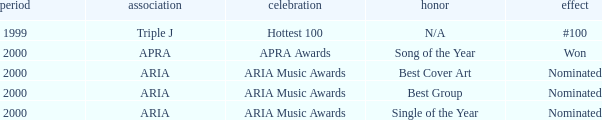What's the award for #100? N/A. 